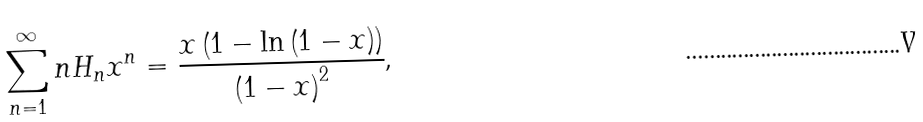<formula> <loc_0><loc_0><loc_500><loc_500>\sum _ { n = 1 } ^ { \infty } n H _ { n } x ^ { n } = \frac { x \left ( 1 - \ln \left ( 1 - x \right ) \right ) } { \left ( 1 - x \right ) ^ { 2 } } \text {,}</formula> 